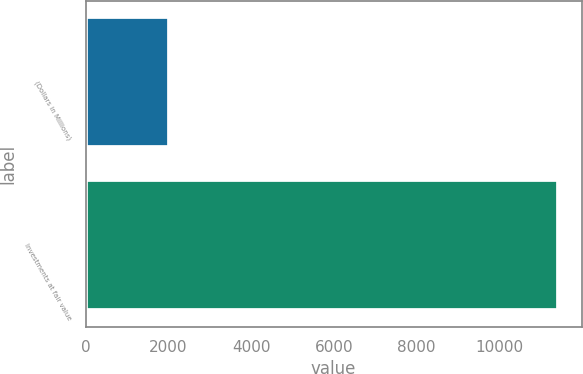<chart> <loc_0><loc_0><loc_500><loc_500><bar_chart><fcel>(Dollars in Millions)<fcel>Investments at fair value<nl><fcel>2018<fcel>11420<nl></chart> 